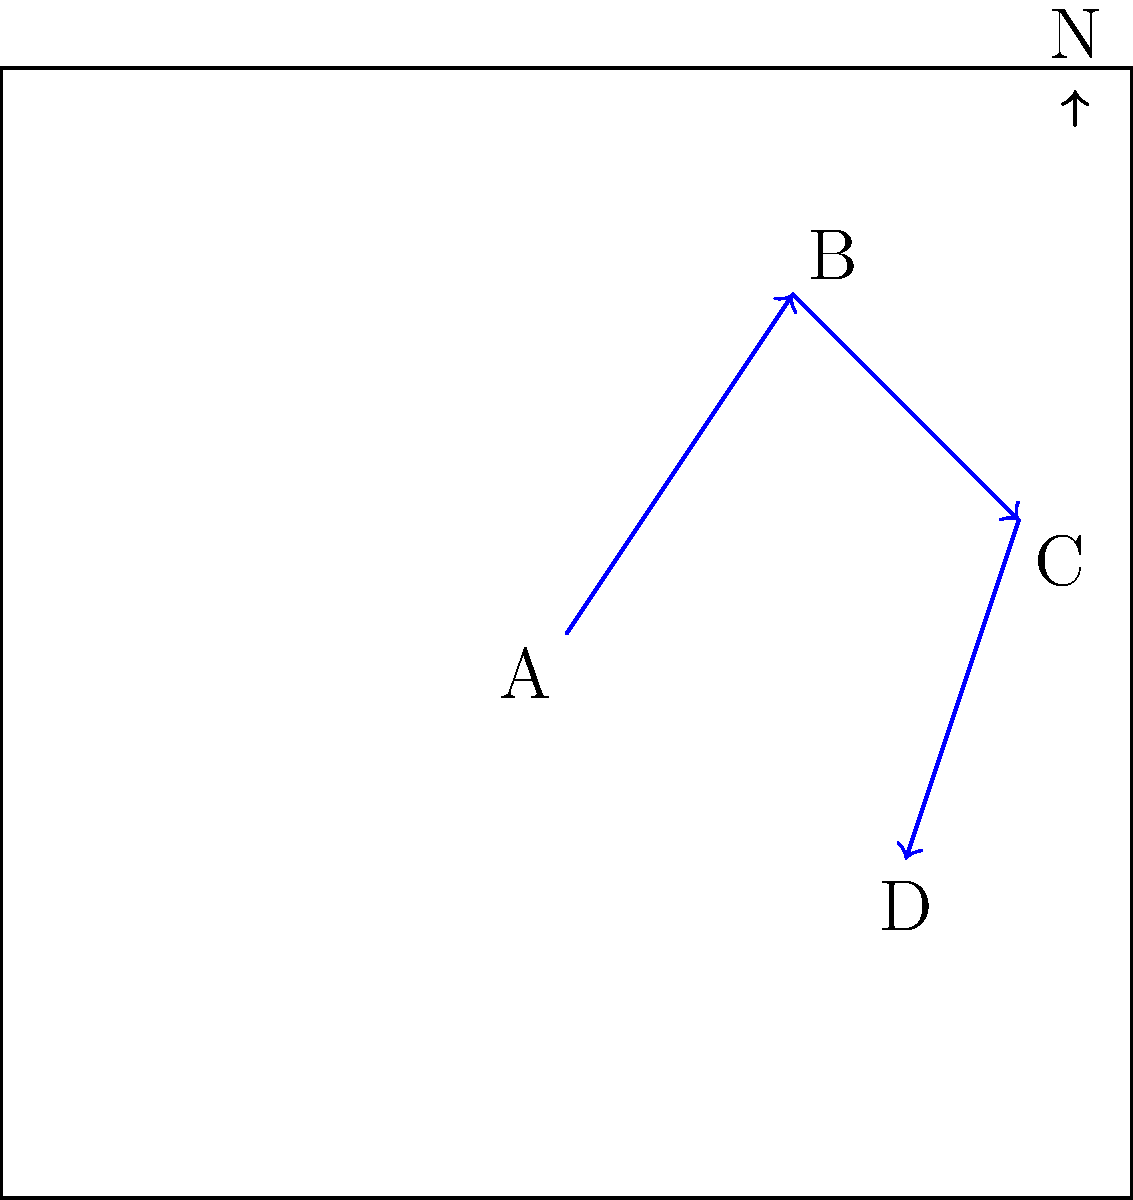As a conservation biologist studying a threatened bird species, you've tracked their migration path using GPS data. The migration is represented by three consecutive vector displacements on a map: $\vec{AB}$, $\vec{BC}$, and $\vec{CD}$. If the total distance traveled by the birds is 10 units, what is the magnitude of the resultant displacement vector $\vec{AD}$? Round your answer to two decimal places. Let's approach this step-by-step:

1) First, we need to find the components of each vector:
   $\vec{AB} = (2,3)$
   $\vec{BC} = (2,-2)$
   $\vec{CD} = (-1,-3)$

2) The resultant displacement vector $\vec{AD}$ is the sum of these vectors:
   $\vec{AD} = \vec{AB} + \vec{BC} + \vec{CD}$

3) Adding the components:
   $\vec{AD} = (2+2-1, 3-2-3) = (3,-2)$

4) To find the magnitude of $\vec{AD}$, we use the Pythagorean theorem:
   $|\vec{AD}| = \sqrt{3^2 + (-2)^2} = \sqrt{9 + 4} = \sqrt{13}$

5) $\sqrt{13} \approx 3.61$ (rounded to two decimal places)

This represents the straight-line distance between the start and end points of the migration, which is less than the total distance traveled (10 units) due to the non-linear path.
Answer: 3.61 units 